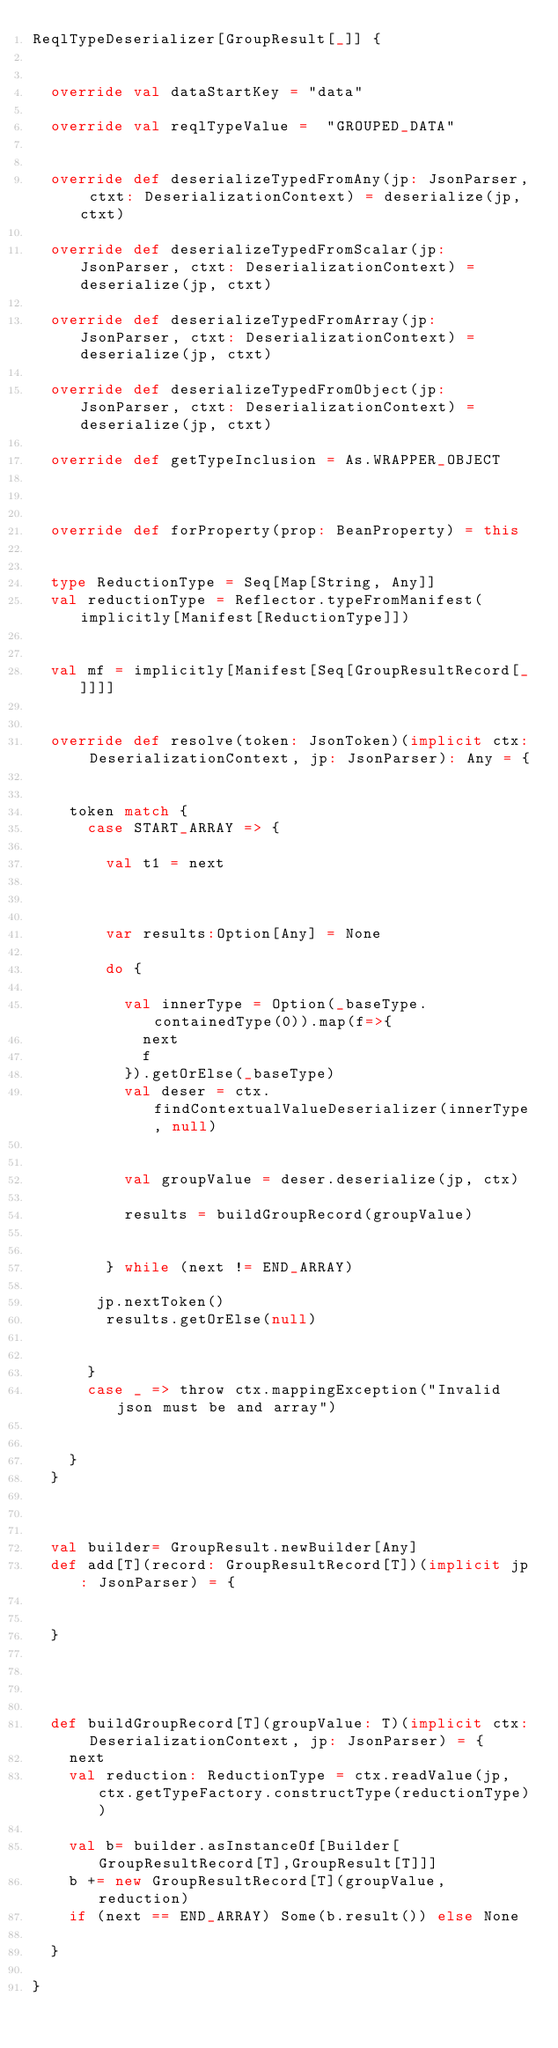<code> <loc_0><loc_0><loc_500><loc_500><_Scala_>ReqlTypeDeserializer[GroupResult[_]] {


  override val dataStartKey = "data"

  override val reqlTypeValue =  "GROUPED_DATA"


  override def deserializeTypedFromAny(jp: JsonParser, ctxt: DeserializationContext) = deserialize(jp, ctxt)

  override def deserializeTypedFromScalar(jp: JsonParser, ctxt: DeserializationContext) = deserialize(jp, ctxt)

  override def deserializeTypedFromArray(jp: JsonParser, ctxt: DeserializationContext) = deserialize(jp, ctxt)

  override def deserializeTypedFromObject(jp: JsonParser, ctxt: DeserializationContext) = deserialize(jp, ctxt)

  override def getTypeInclusion = As.WRAPPER_OBJECT



  override def forProperty(prop: BeanProperty) = this


  type ReductionType = Seq[Map[String, Any]]
  val reductionType = Reflector.typeFromManifest(implicitly[Manifest[ReductionType]])


  val mf = implicitly[Manifest[Seq[GroupResultRecord[_]]]]


  override def resolve(token: JsonToken)(implicit ctx: DeserializationContext, jp: JsonParser): Any = {


    token match {
      case START_ARRAY => {

        val t1 = next



        var results:Option[Any] = None

        do {

          val innerType = Option(_baseType.containedType(0)).map(f=>{
            next
            f
          }).getOrElse(_baseType)
          val deser = ctx.findContextualValueDeserializer(innerType, null)


          val groupValue = deser.deserialize(jp, ctx)

          results = buildGroupRecord(groupValue)


        } while (next != END_ARRAY)

       jp.nextToken()
        results.getOrElse(null)


      }
      case _ => throw ctx.mappingException("Invalid json must be and array")


    }
  }



  val builder= GroupResult.newBuilder[Any]
  def add[T](record: GroupResultRecord[T])(implicit jp: JsonParser) = {


  }




  def buildGroupRecord[T](groupValue: T)(implicit ctx: DeserializationContext, jp: JsonParser) = {
    next
    val reduction: ReductionType = ctx.readValue(jp, ctx.getTypeFactory.constructType(reductionType))

    val b= builder.asInstanceOf[Builder[GroupResultRecord[T],GroupResult[T]]]
    b += new GroupResultRecord[T](groupValue, reduction)
    if (next == END_ARRAY) Some(b.result()) else None

  }

}
</code> 